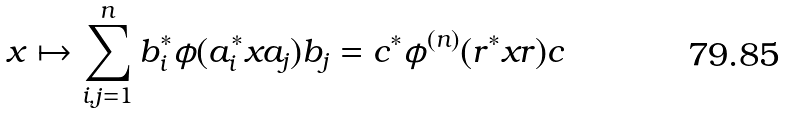Convert formula to latex. <formula><loc_0><loc_0><loc_500><loc_500>x \mapsto \sum _ { i , j = 1 } ^ { n } b _ { i } ^ { \ast } \phi ( a _ { i } ^ { \ast } x a _ { j } ) b _ { j } = c ^ { \ast } \phi ^ { ( n ) } ( r ^ { \ast } x r ) c</formula> 